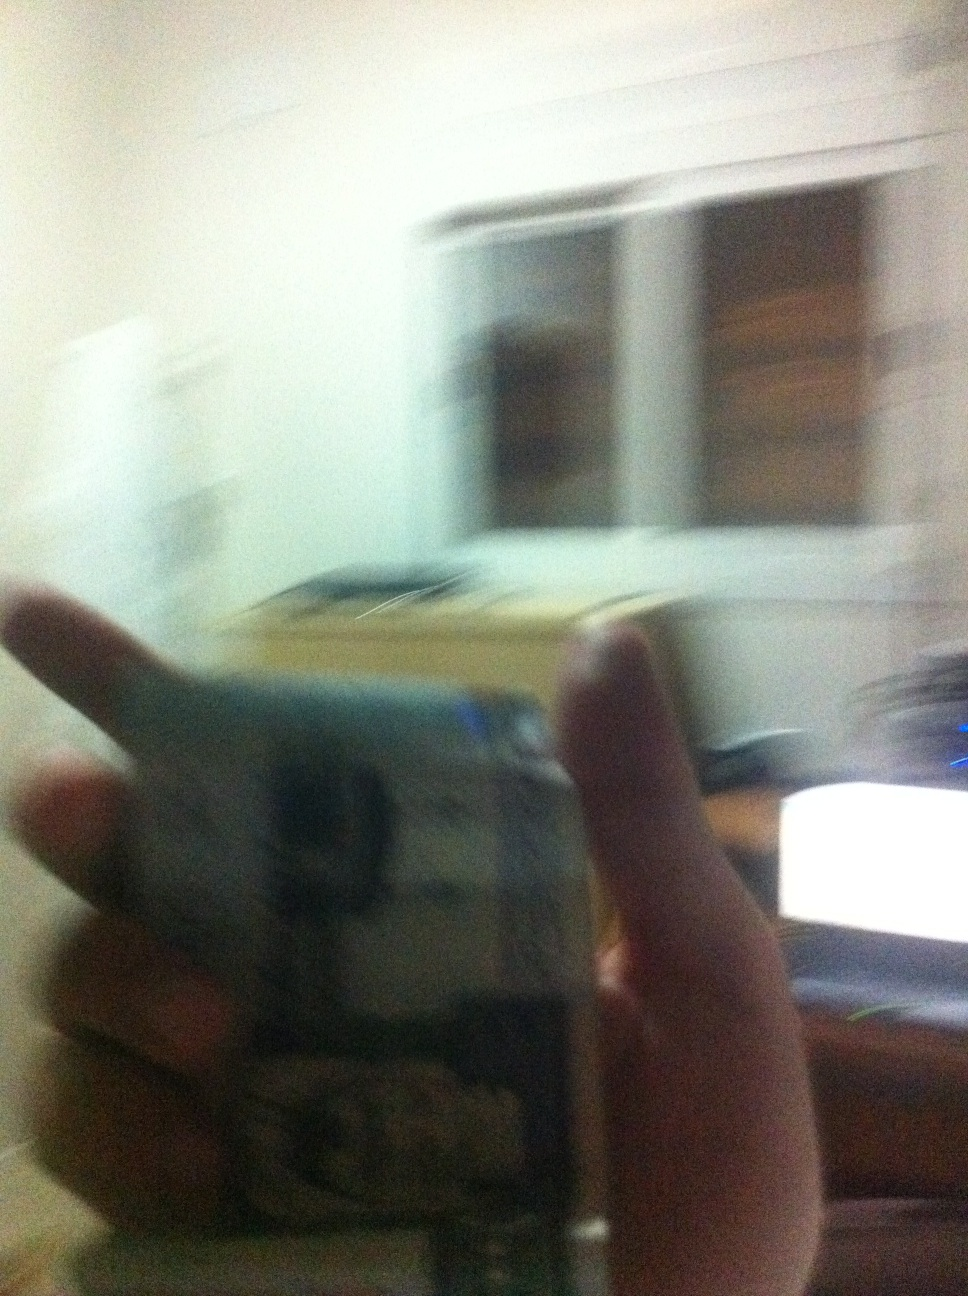Imagine this currency could talk. What story would it tell? If this currency could talk, it might say, 'I've traveled through various hands, each with a unique story. I've been used to buy groceries for a family, given as a gift, or even saved as a small fortune. Though I'm just a piece of paper, I've been part of many life's moments, shaping stories of joy, struggle, and everyday life.' 